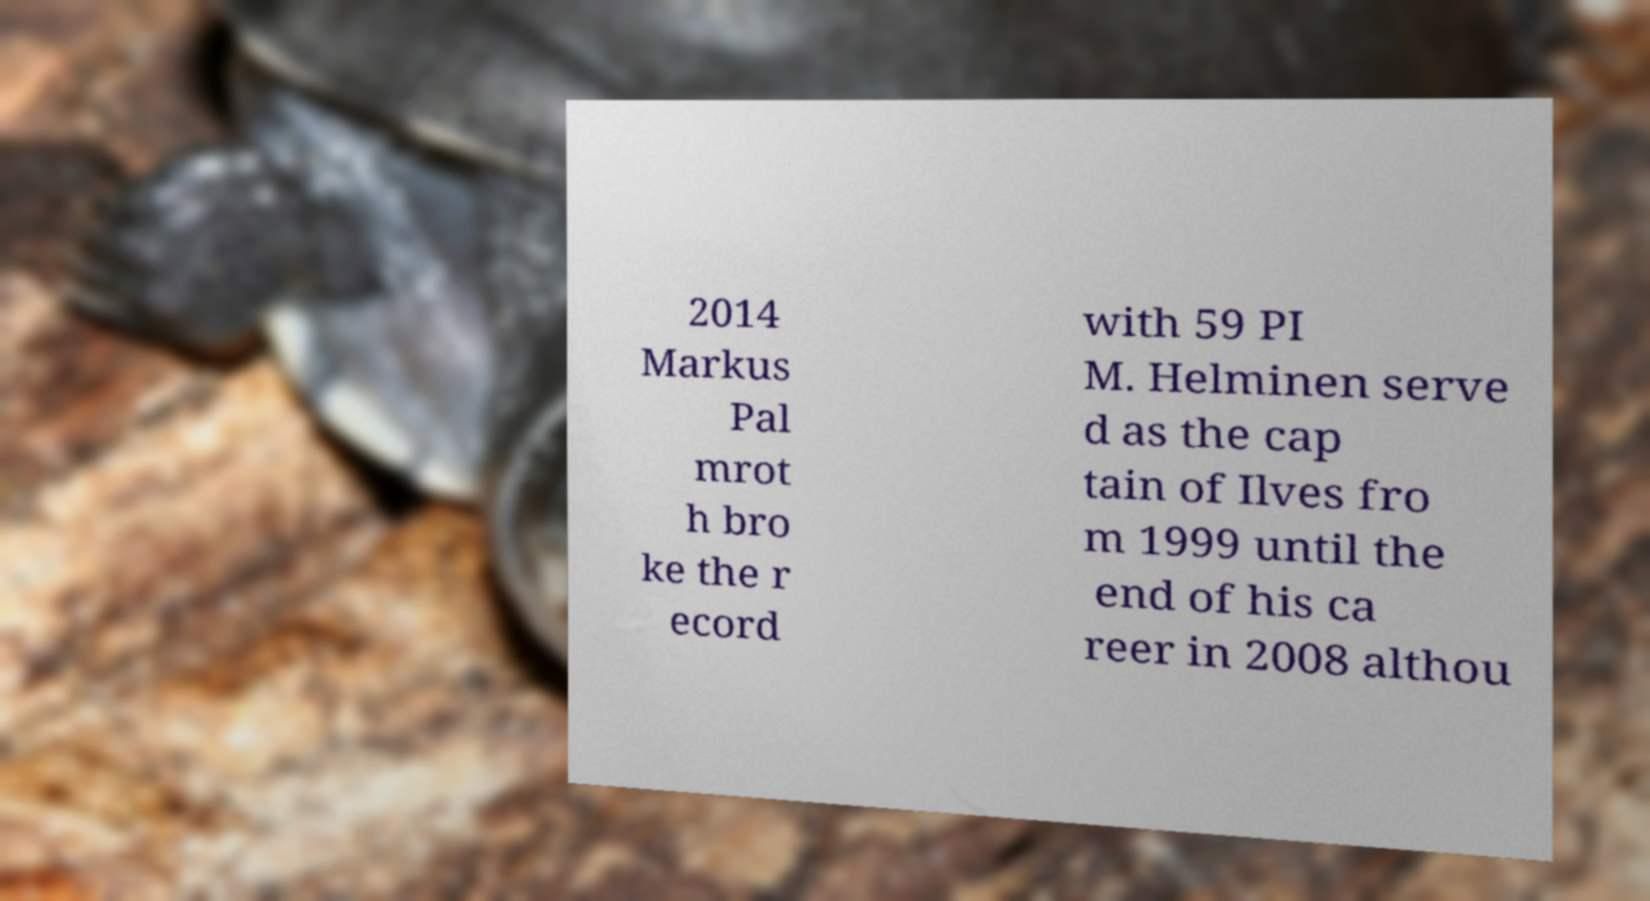Can you accurately transcribe the text from the provided image for me? 2014 Markus Pal mrot h bro ke the r ecord with 59 PI M. Helminen serve d as the cap tain of Ilves fro m 1999 until the end of his ca reer in 2008 althou 